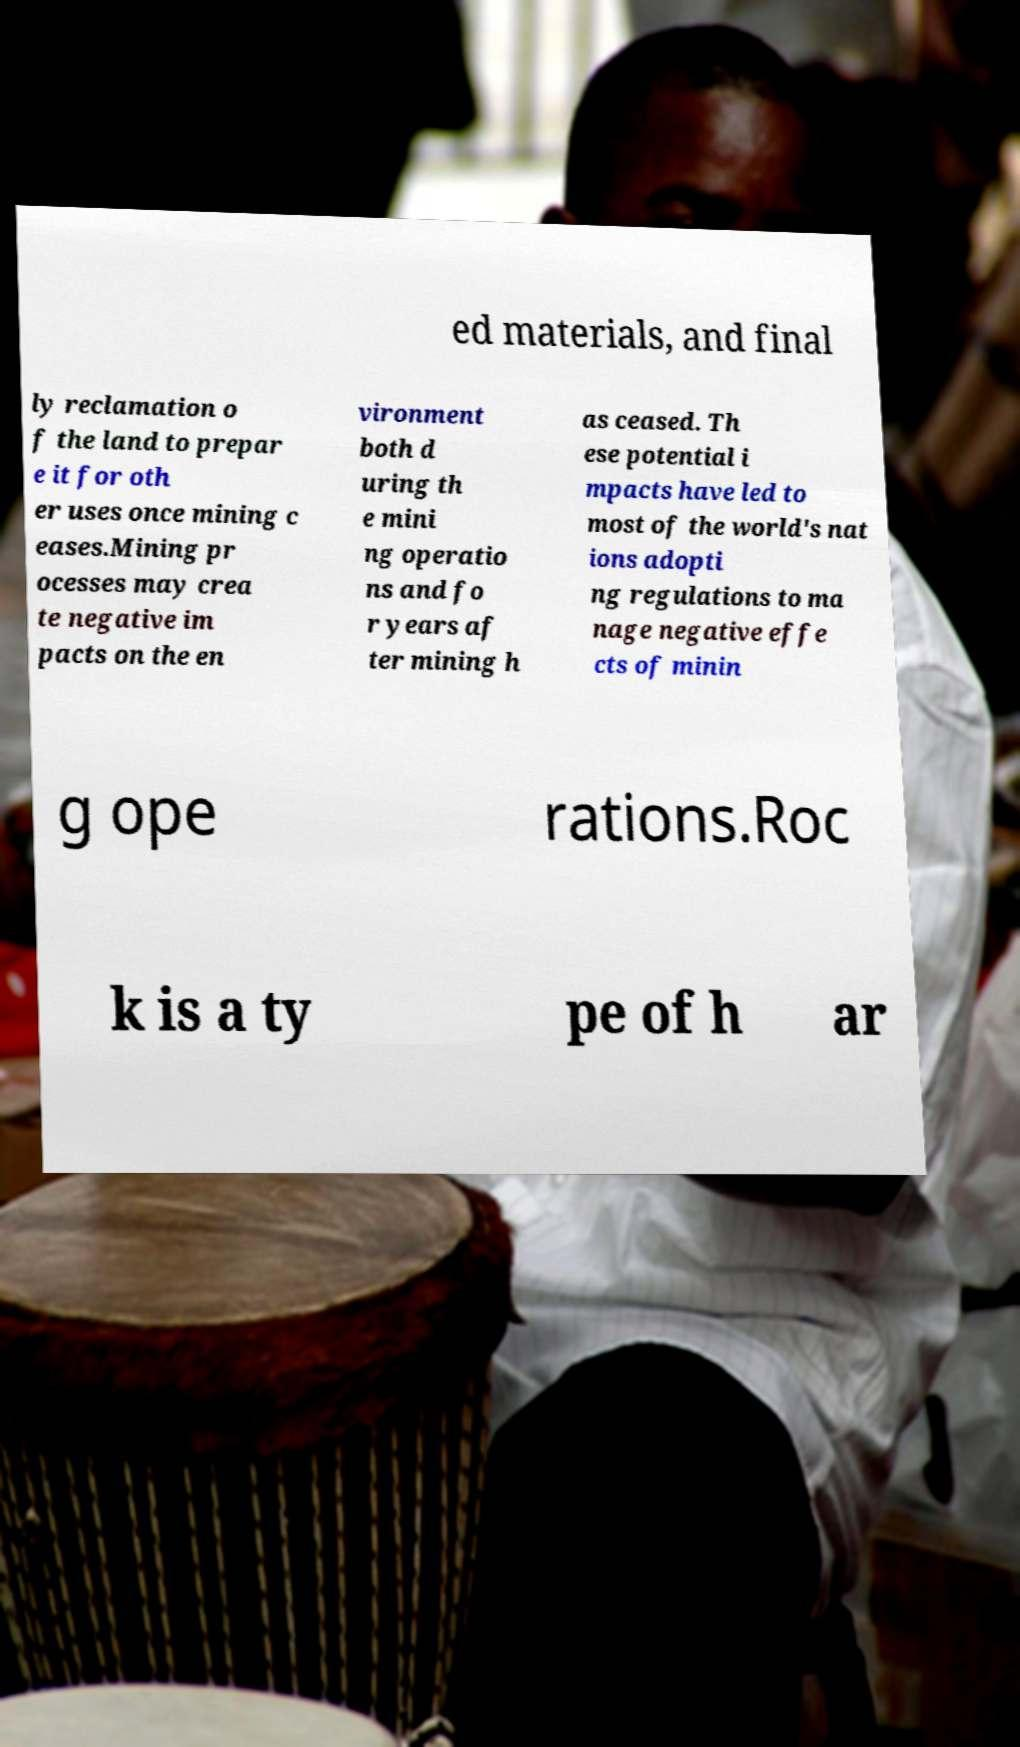There's text embedded in this image that I need extracted. Can you transcribe it verbatim? ed materials, and final ly reclamation o f the land to prepar e it for oth er uses once mining c eases.Mining pr ocesses may crea te negative im pacts on the en vironment both d uring th e mini ng operatio ns and fo r years af ter mining h as ceased. Th ese potential i mpacts have led to most of the world's nat ions adopti ng regulations to ma nage negative effe cts of minin g ope rations.Roc k is a ty pe of h ar 